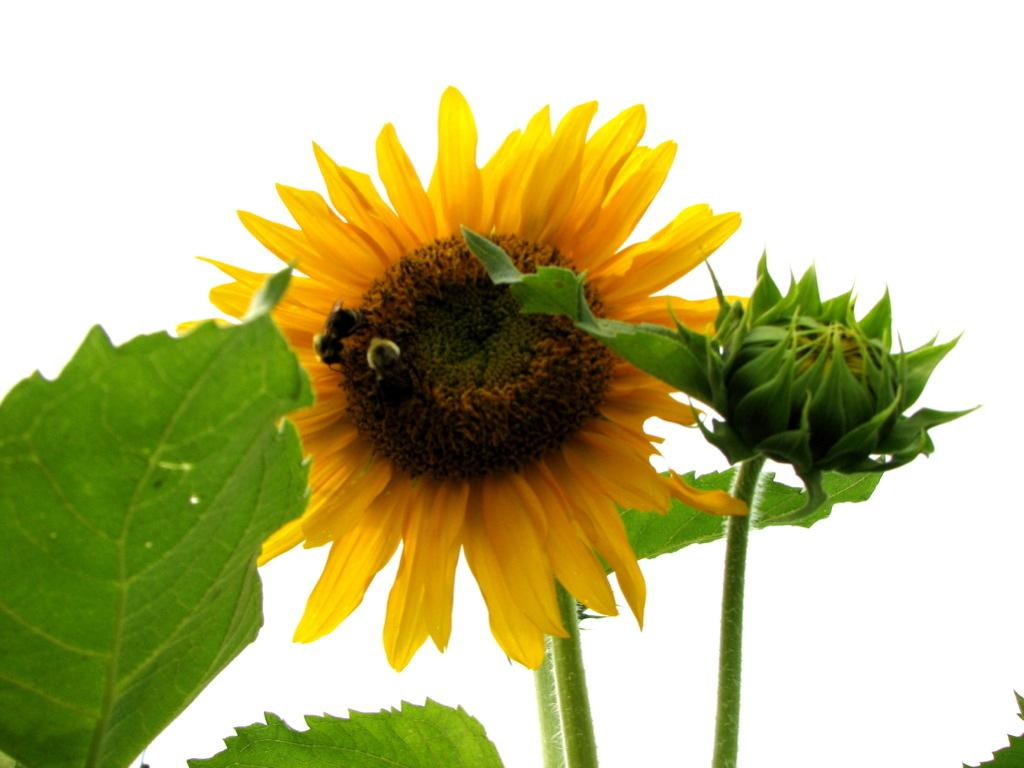What is on the flower in the image? There is an insect on a flower in the image. What is the stage of the plant's growth in the image? There is a bud on the stem of a plant in the image. What type of vegetation is present beside the plant? There are leaves beside the plant in the image. What type of steel is used to construct the hospital in the image? There is no hospital present in the image, and therefore no steel construction can be observed. 